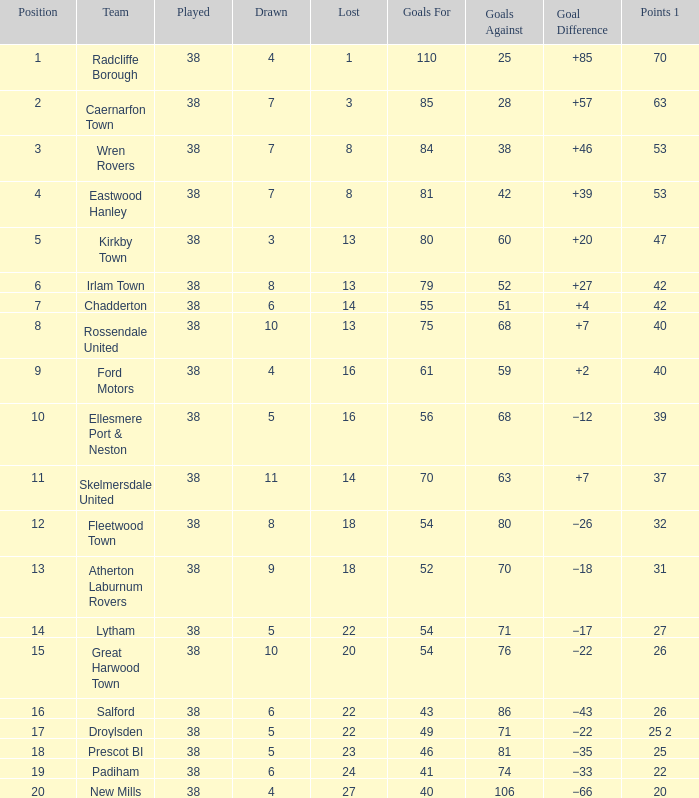Who is the player with 4 draws, a 9th position, and over 59 goals scored against them? None. Parse the table in full. {'header': ['Position', 'Team', 'Played', 'Drawn', 'Lost', 'Goals For', 'Goals Against', 'Goal Difference', 'Points 1'], 'rows': [['1', 'Radcliffe Borough', '38', '4', '1', '110', '25', '+85', '70'], ['2', 'Caernarfon Town', '38', '7', '3', '85', '28', '+57', '63'], ['3', 'Wren Rovers', '38', '7', '8', '84', '38', '+46', '53'], ['4', 'Eastwood Hanley', '38', '7', '8', '81', '42', '+39', '53'], ['5', 'Kirkby Town', '38', '3', '13', '80', '60', '+20', '47'], ['6', 'Irlam Town', '38', '8', '13', '79', '52', '+27', '42'], ['7', 'Chadderton', '38', '6', '14', '55', '51', '+4', '42'], ['8', 'Rossendale United', '38', '10', '13', '75', '68', '+7', '40'], ['9', 'Ford Motors', '38', '4', '16', '61', '59', '+2', '40'], ['10', 'Ellesmere Port & Neston', '38', '5', '16', '56', '68', '−12', '39'], ['11', 'Skelmersdale United', '38', '11', '14', '70', '63', '+7', '37'], ['12', 'Fleetwood Town', '38', '8', '18', '54', '80', '−26', '32'], ['13', 'Atherton Laburnum Rovers', '38', '9', '18', '52', '70', '−18', '31'], ['14', 'Lytham', '38', '5', '22', '54', '71', '−17', '27'], ['15', 'Great Harwood Town', '38', '10', '20', '54', '76', '−22', '26'], ['16', 'Salford', '38', '6', '22', '43', '86', '−43', '26'], ['17', 'Droylsden', '38', '5', '22', '49', '71', '−22', '25 2'], ['18', 'Prescot BI', '38', '5', '23', '46', '81', '−35', '25'], ['19', 'Padiham', '38', '6', '24', '41', '74', '−33', '22'], ['20', 'New Mills', '38', '4', '27', '40', '106', '−66', '20']]} 